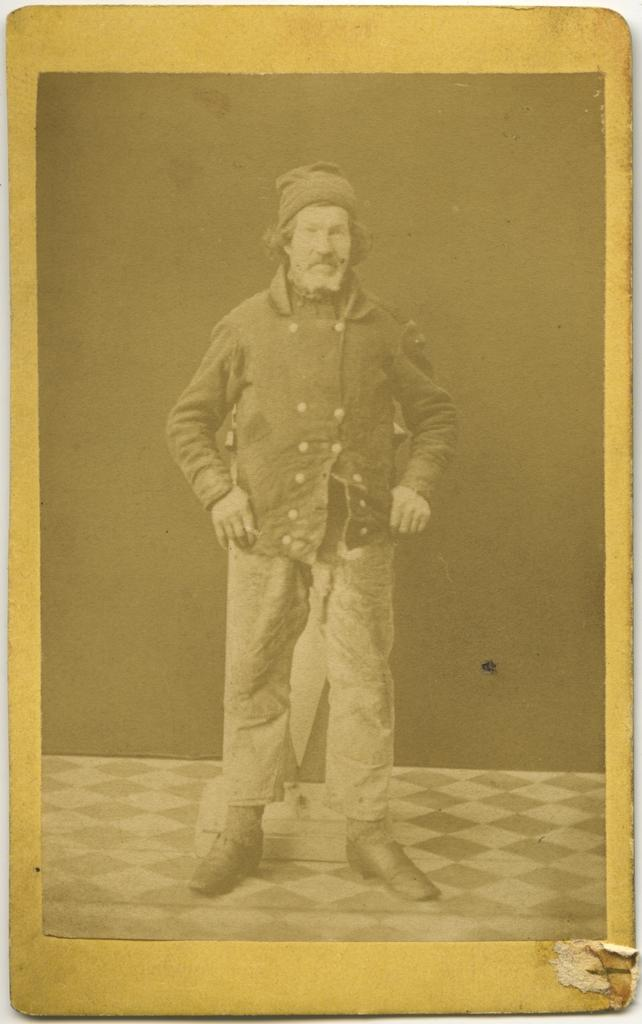What is displayed on the board in the image? There is a photo on a board in the image. What can be seen in the photo? The photo contains an image of a man. What is the man doing in the photo? The man is standing on the floor in the photo. What type of rod is the man holding in the photo? There is no rod present in the photo; the man is simply standing on the floor. 